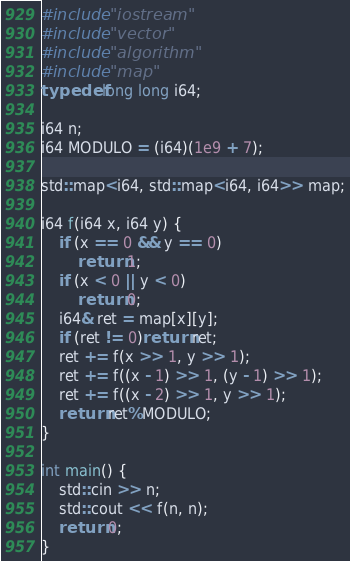Convert code to text. <code><loc_0><loc_0><loc_500><loc_500><_C++_>#include "iostream"
#include "vector"
#include "algorithm"
#include "map"
typedef long long i64;

i64 n;
i64 MODULO = (i64)(1e9 + 7);

std::map<i64, std::map<i64, i64>> map;

i64 f(i64 x, i64 y) {
	if (x == 0 && y == 0)
		return 1;
	if (x < 0 || y < 0)
		return 0;
	i64& ret = map[x][y];
	if (ret != 0)return ret;
	ret += f(x >> 1, y >> 1);
	ret += f((x - 1) >> 1, (y - 1) >> 1);
	ret += f((x - 2) >> 1, y >> 1);
	return ret%MODULO;
}

int main() {
	std::cin >> n;
	std::cout << f(n, n);
	return 0;
}


</code> 